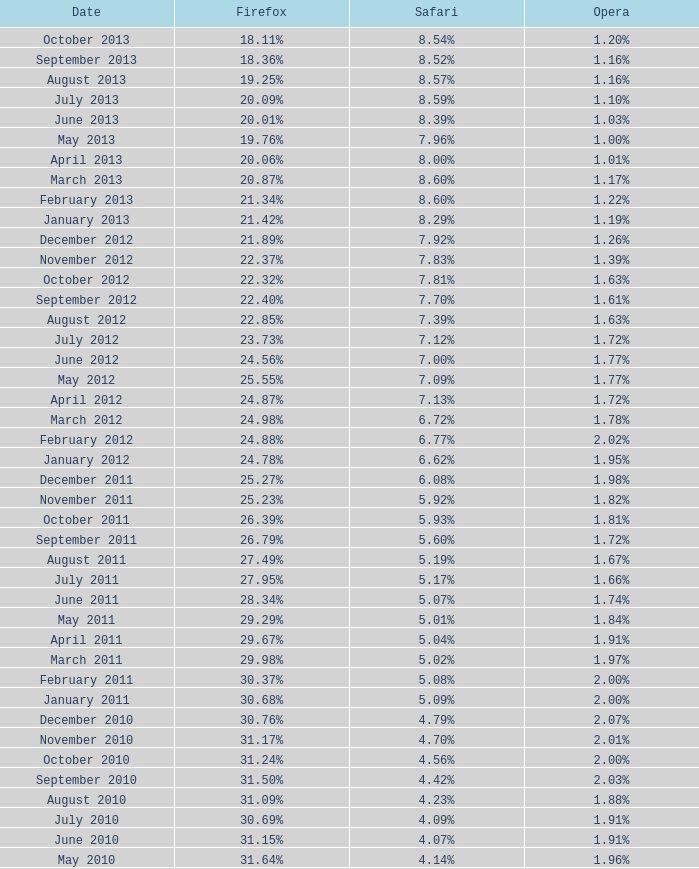In november 2009, what was the proportion of browsers utilizing opera? 2.02%. 